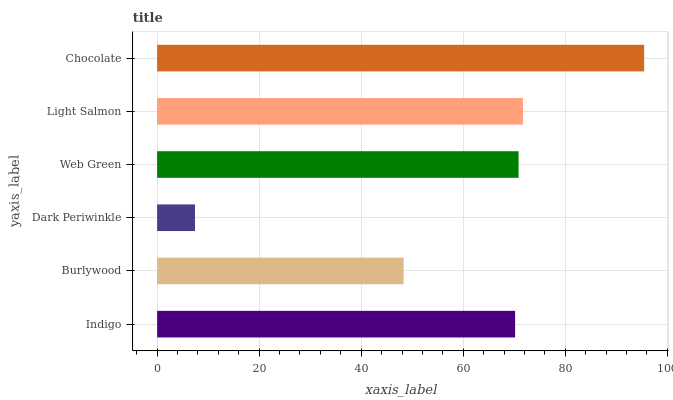Is Dark Periwinkle the minimum?
Answer yes or no. Yes. Is Chocolate the maximum?
Answer yes or no. Yes. Is Burlywood the minimum?
Answer yes or no. No. Is Burlywood the maximum?
Answer yes or no. No. Is Indigo greater than Burlywood?
Answer yes or no. Yes. Is Burlywood less than Indigo?
Answer yes or no. Yes. Is Burlywood greater than Indigo?
Answer yes or no. No. Is Indigo less than Burlywood?
Answer yes or no. No. Is Web Green the high median?
Answer yes or no. Yes. Is Indigo the low median?
Answer yes or no. Yes. Is Light Salmon the high median?
Answer yes or no. No. Is Web Green the low median?
Answer yes or no. No. 